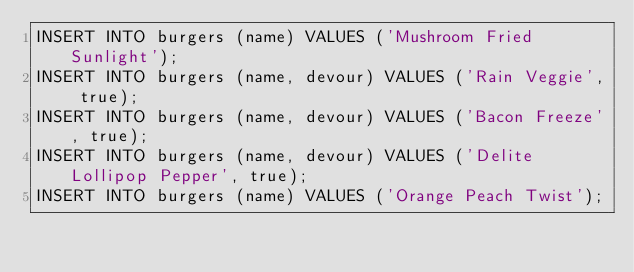<code> <loc_0><loc_0><loc_500><loc_500><_SQL_>INSERT INTO burgers (name) VALUES ('Mushroom Fried Sunlight');
INSERT INTO burgers (name, devour) VALUES ('Rain Veggie', true);
INSERT INTO burgers (name, devour) VALUES ('Bacon Freeze', true);
INSERT INTO burgers (name, devour) VALUES ('Delite Lollipop Pepper', true);
INSERT INTO burgers (name) VALUES ('Orange Peach Twist');
</code> 